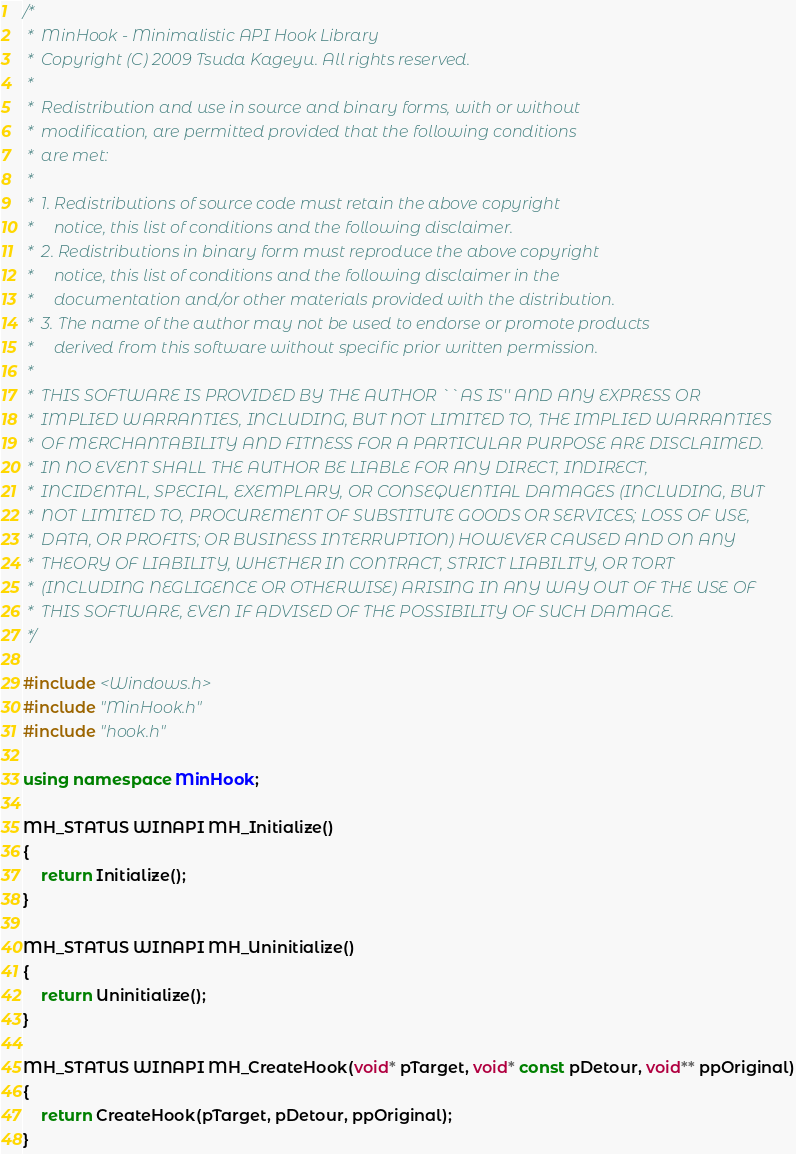Convert code to text. <code><loc_0><loc_0><loc_500><loc_500><_C++_>/* 
 *  MinHook - Minimalistic API Hook Library	
 *  Copyright (C) 2009 Tsuda Kageyu. All rights reserved.
 *  
 *  Redistribution and use in source and binary forms, with or without
 *  modification, are permitted provided that the following conditions
 *  are met:
 *  
 *  1. Redistributions of source code must retain the above copyright
 *     notice, this list of conditions and the following disclaimer.
 *  2. Redistributions in binary form must reproduce the above copyright
 *     notice, this list of conditions and the following disclaimer in the
 *     documentation and/or other materials provided with the distribution.
 *  3. The name of the author may not be used to endorse or promote products
 *     derived from this software without specific prior written permission.
 *  
 *  THIS SOFTWARE IS PROVIDED BY THE AUTHOR ``AS IS'' AND ANY EXPRESS OR
 *  IMPLIED WARRANTIES, INCLUDING, BUT NOT LIMITED TO, THE IMPLIED WARRANTIES
 *  OF MERCHANTABILITY AND FITNESS FOR A PARTICULAR PURPOSE ARE DISCLAIMED.
 *  IN NO EVENT SHALL THE AUTHOR BE LIABLE FOR ANY DIRECT, INDIRECT,
 *  INCIDENTAL, SPECIAL, EXEMPLARY, OR CONSEQUENTIAL DAMAGES (INCLUDING, BUT
 *  NOT LIMITED TO, PROCUREMENT OF SUBSTITUTE GOODS OR SERVICES; LOSS OF USE,
 *  DATA, OR PROFITS; OR BUSINESS INTERRUPTION) HOWEVER CAUSED AND ON ANY
 *  THEORY OF LIABILITY, WHETHER IN CONTRACT, STRICT LIABILITY, OR TORT
 *  (INCLUDING NEGLIGENCE OR OTHERWISE) ARISING IN ANY WAY OUT OF THE USE OF
 *  THIS SOFTWARE, EVEN IF ADVISED OF THE POSSIBILITY OF SUCH DAMAGE.
 */

#include <Windows.h>
#include "MinHook.h"
#include "hook.h"

using namespace MinHook;

MH_STATUS WINAPI MH_Initialize()
{
	return Initialize();
}

MH_STATUS WINAPI MH_Uninitialize()
{
	return Uninitialize();
}

MH_STATUS WINAPI MH_CreateHook(void* pTarget, void* const pDetour, void** ppOriginal)
{
	return CreateHook(pTarget, pDetour, ppOriginal);
}
</code> 